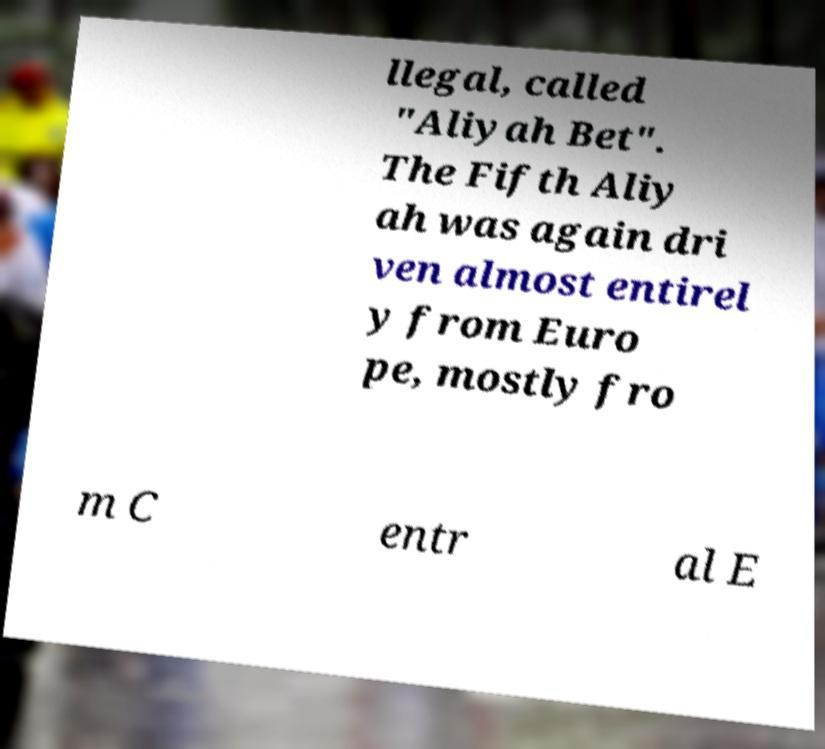There's text embedded in this image that I need extracted. Can you transcribe it verbatim? llegal, called "Aliyah Bet". The Fifth Aliy ah was again dri ven almost entirel y from Euro pe, mostly fro m C entr al E 